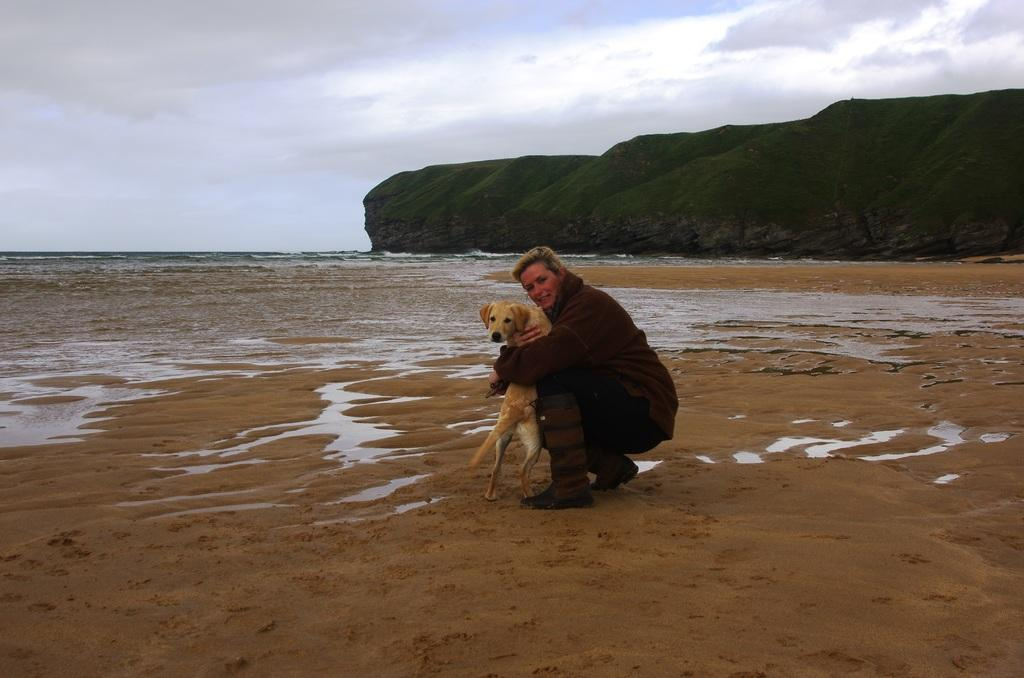Who or what is the main subject in the image? There is a person in the image. What is the person doing in the image? The person is holding a dog. Where does the scene take place? The scene takes place at a sea shore. What other geographical feature can be seen in the image? There is a hill visible in the image. What type of secretary can be seen working in the image? There is no secretary present in the image; it features a person holding a dog at a sea shore with a hill in the background. 